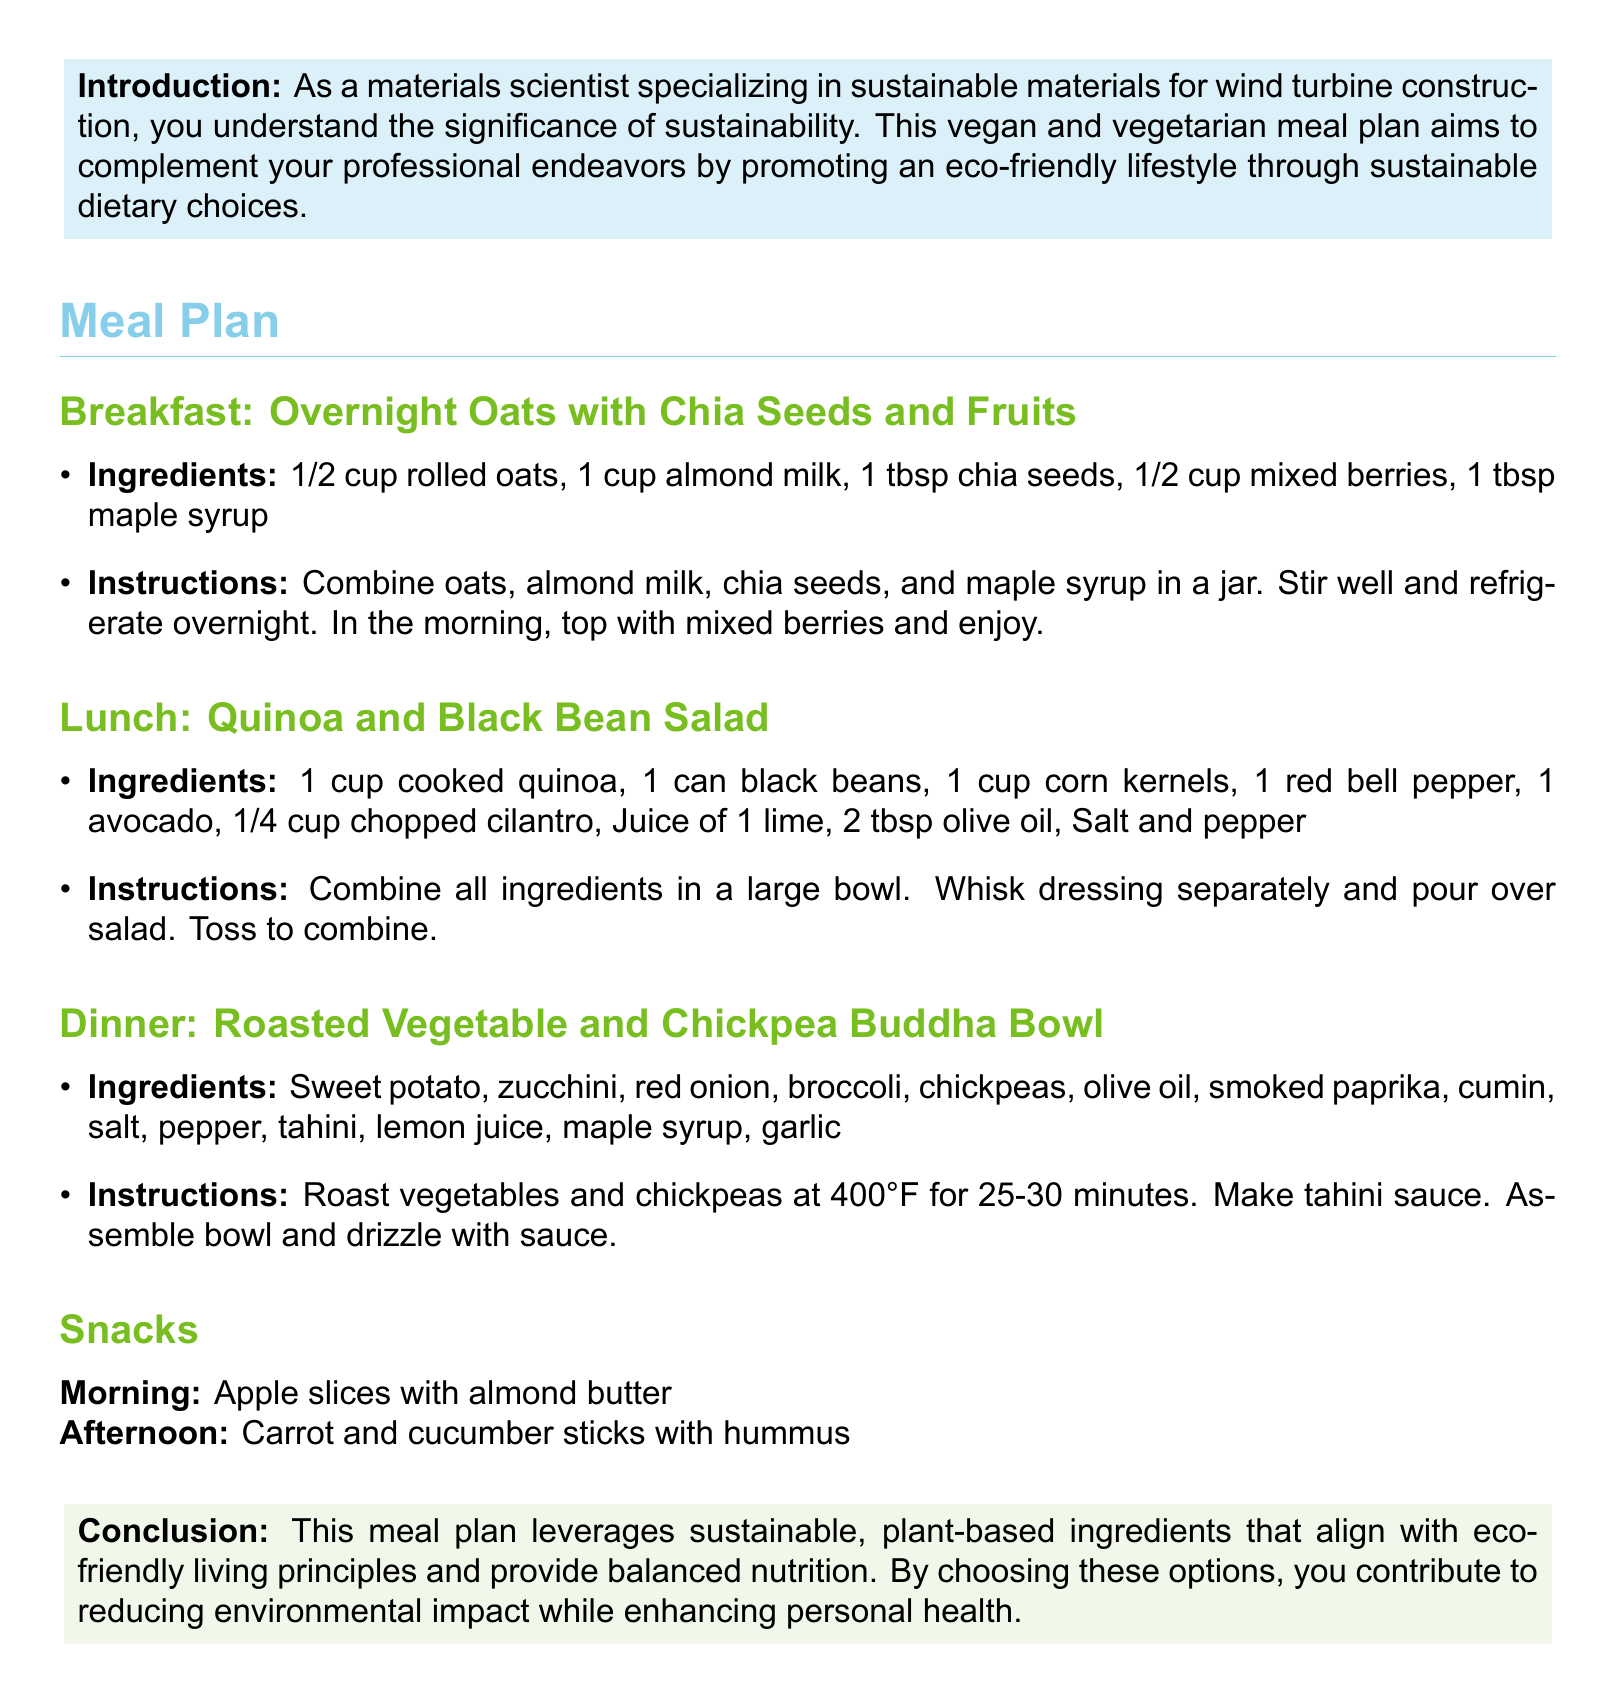What is the first meal listed in the plan? The first meal in the plan is breakfast, which consists of overnight oats with chia seeds and fruits.
Answer: Overnight Oats with Chia Seeds and Fruits What ingredient is used in the lunch salad that provides healthy fats? The ingredient in the salad that provides healthy fats is avocado.
Answer: Avocado How long should vegetables and chickpeas be roasted? The document specifies that vegetables and chickpeas should be roasted for 25-30 minutes at 400°F.
Answer: 25-30 minutes What type of milk is used in the breakfast recipe? The breakfast recipe calls for almond milk.
Answer: Almond milk What is the primary source of protein in the lunch meal? The primary source of protein in the quinoa and black bean salad is black beans.
Answer: Black beans What sauce is drizzled on the Buddha bowl? The document mentions that tahini sauce is drizzled on the Buddha bowl.
Answer: Tahini sauce What fruit is suggested as a morning snack? The document suggests apple slices as a morning snack.
Answer: Apple slices What color is associated with the conclusion box? The conclusion box is associated with the color leaf green.
Answer: Leaf green What is recommended as an afternoon snack? The document recommends carrot and cucumber sticks with hummus as an afternoon snack.
Answer: Carrot and cucumber sticks with hummus 